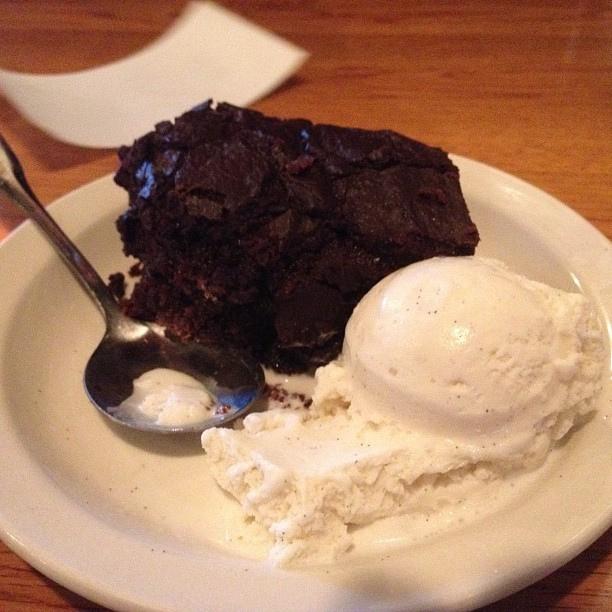Is the ice cream chocolate?
Keep it brief. No. Is this meal hot?
Be succinct. No. What is the ice cream on?
Short answer required. Plate. 